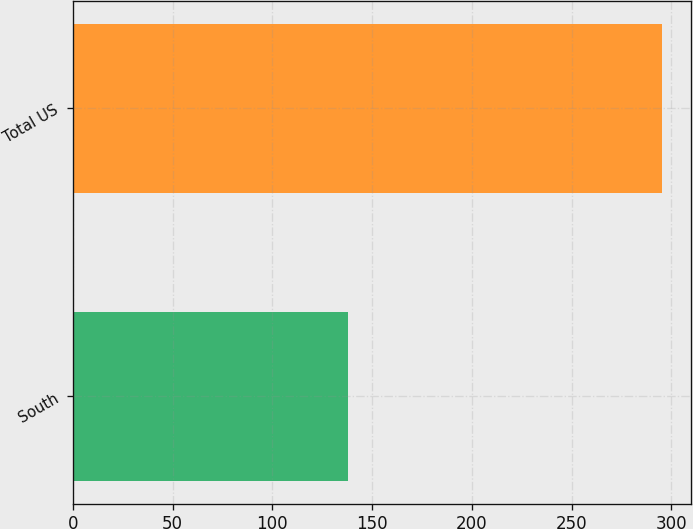<chart> <loc_0><loc_0><loc_500><loc_500><bar_chart><fcel>South<fcel>Total US<nl><fcel>138<fcel>295<nl></chart> 